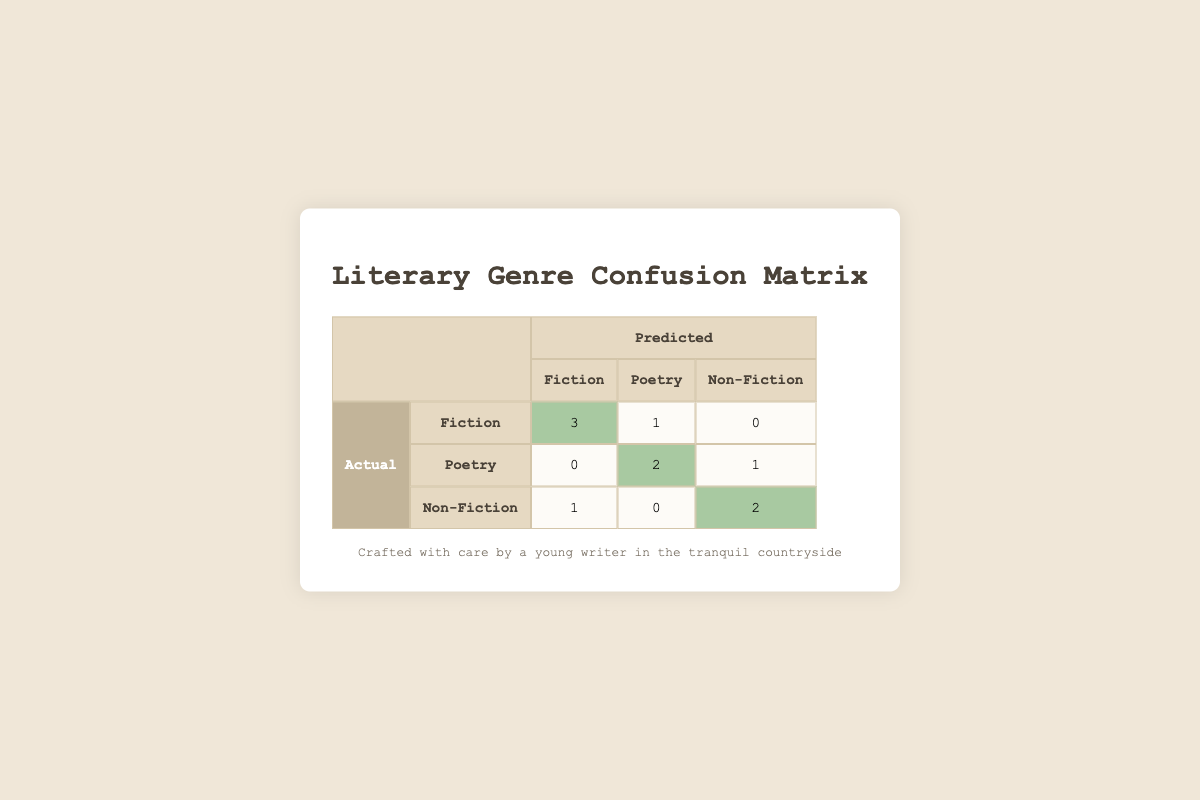What is the number of short stories classified as Fiction? The table shows that in the Actual row for Fiction, the predicted value for Fiction is 3. Therefore, the number of short stories classified as Fiction is 3.
Answer: 3 How many short stories were incorrectly classified as Non-Fiction? Looking at the Non-Fiction actuals, the table indicates that there is 1 story incorrectly classified as Fiction and 0 as Poetry. Therefore, a total of 1 story was incorrectly classified as Non-Fiction.
Answer: 1 What is the total number of Poetry stories predicted correctly? From the table, the Actual row for Poetry shows 2 correctly predicted stories (highlighted), so the total number of Poetry stories predicted correctly is 2.
Answer: 2 How many total stories were predicted to be Fiction? By examining the columns under the predicted Fiction, we see 3 stories from the Actual Fiction and 0 from Actual Poetry and 1 from Actual Non-Fiction. Summing these gives us 3 + 0 + 1 = 4.
Answer: 4 Is it true that all Non-Fiction stories were predicted correctly? The table shows that under the Non-Fiction actuals, there are 2 stories predicted correctly. Since there are 3 Non-Fiction stories total, not all were predicted correctly. Therefore, the answer is false.
Answer: False What is the sum of stories predicted correctly across all categories? To find the sum of correctly predicted stories, we add stories: 3 (Fiction) + 2 (Poetry) + 2 (Non-Fiction) = 7. Thus, the sum of stories predicted correctly across all categories is 7.
Answer: 7 How many Poetry stories were misclassified as Fiction? Looking at the table, the Actual row for Poetry has 1 story predicted as Fiction, indicating that this one story was misclassified as Fiction.
Answer: 1 If you sum the misclassifications for all genres, what will the result be? The misclassifications can be calculated as follows: for Fiction (1), for Poetry (1), and for Non-Fiction (1). Summing these gives 1 + 1 + 1 = 3. So the total number of misclassifications is 3.
Answer: 3 